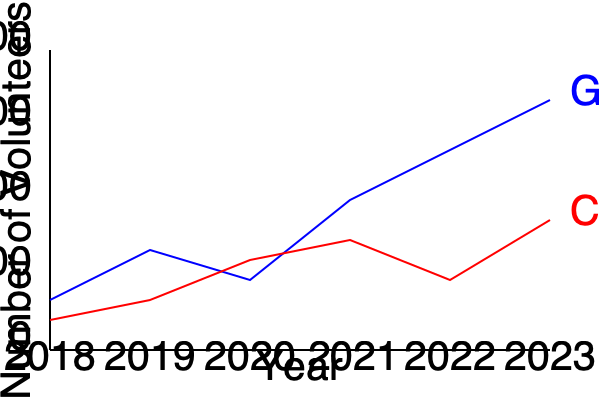As a grassroots organizer, you're analyzing volunteer participation trends. The blue line represents graduate student volunteers, while the red line shows community member volunteers. In which year did the number of graduate student volunteers surpass the number of community member volunteers for the first time? To determine when graduate student volunteers first surpassed community member volunteers, we need to compare the two lines year by year:

1. 2018: Blue line (graduate students) is below red line (community members).
2. 2019: Blue line is still below red line.
3. 2020: Blue line is above red line for the first time.
4. 2021-2023: Blue line remains above red line.

The blue line first crosses above the red line in 2020, indicating that graduate student volunteers outnumbered community member volunteers for the first time in that year.
Answer: 2020 